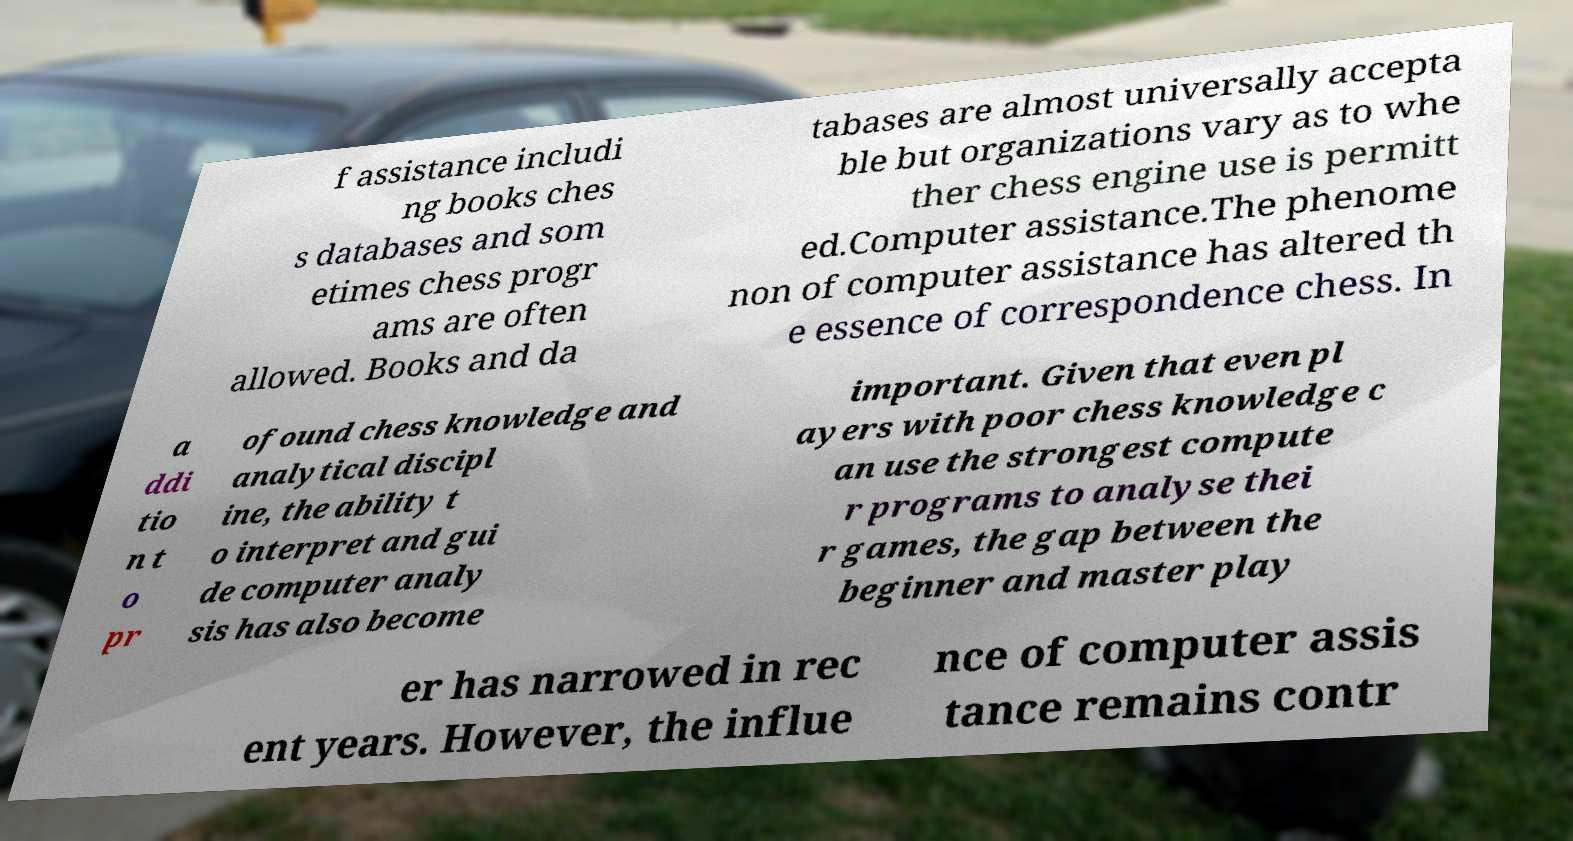Please identify and transcribe the text found in this image. f assistance includi ng books ches s databases and som etimes chess progr ams are often allowed. Books and da tabases are almost universally accepta ble but organizations vary as to whe ther chess engine use is permitt ed.Computer assistance.The phenome non of computer assistance has altered th e essence of correspondence chess. In a ddi tio n t o pr ofound chess knowledge and analytical discipl ine, the ability t o interpret and gui de computer analy sis has also become important. Given that even pl ayers with poor chess knowledge c an use the strongest compute r programs to analyse thei r games, the gap between the beginner and master play er has narrowed in rec ent years. However, the influe nce of computer assis tance remains contr 